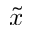<formula> <loc_0><loc_0><loc_500><loc_500>\tilde { x }</formula> 